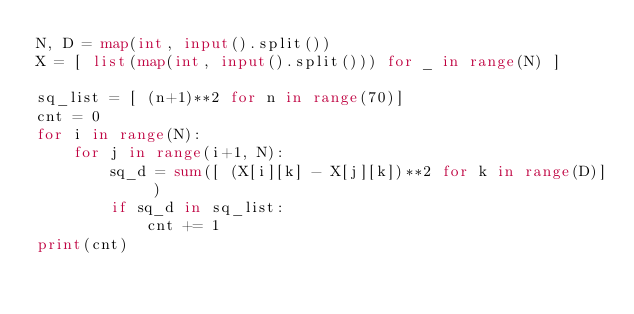<code> <loc_0><loc_0><loc_500><loc_500><_Python_>N, D = map(int, input().split())
X = [ list(map(int, input().split())) for _ in range(N) ]

sq_list = [ (n+1)**2 for n in range(70)]
cnt = 0
for i in range(N):
    for j in range(i+1, N):
        sq_d = sum([ (X[i][k] - X[j][k])**2 for k in range(D)] )
        if sq_d in sq_list:
            cnt += 1
print(cnt)</code> 